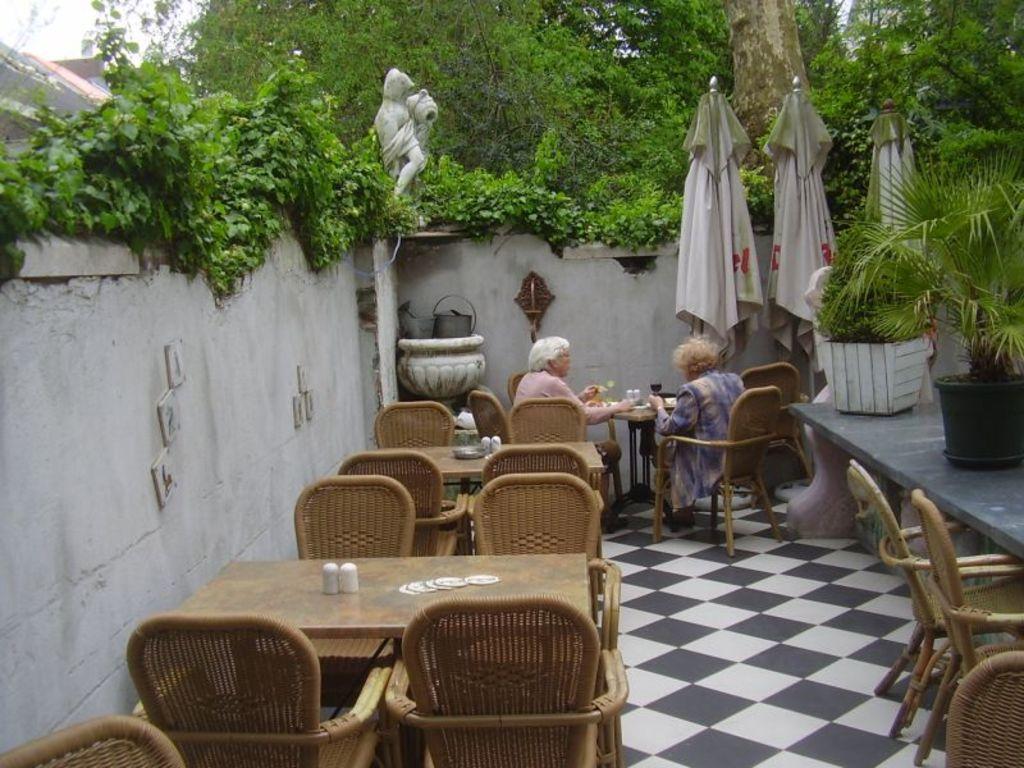In one or two sentences, can you explain what this image depicts? In this picture e can see two woman sitting on chair and in front of them there is table and on table we can see glasses and in background we can see wall, pot, trees, statue, umbrellas, flower pots with plant in it. 